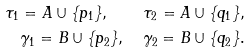Convert formula to latex. <formula><loc_0><loc_0><loc_500><loc_500>\tau _ { 1 } = A \cup \{ p _ { 1 } \} , \quad \tau _ { 2 } = A \cup \{ q _ { 1 } \} , \\ \gamma _ { 1 } = B \cup \{ p _ { 2 } \} , \quad \gamma _ { 2 } = B \cup \{ q _ { 2 } \} .</formula> 